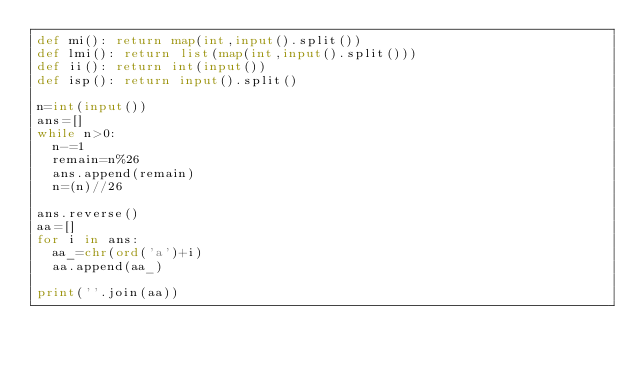Convert code to text. <code><loc_0><loc_0><loc_500><loc_500><_Python_>def mi(): return map(int,input().split())
def lmi(): return list(map(int,input().split()))
def ii(): return int(input())
def isp(): return input().split()

n=int(input())
ans=[]
while n>0:
  n-=1
  remain=n%26
  ans.append(remain)
  n=(n)//26
  
ans.reverse()
aa=[]
for i in ans:
  aa_=chr(ord('a')+i)
  aa.append(aa_)
  
print(''.join(aa))</code> 